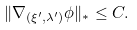Convert formula to latex. <formula><loc_0><loc_0><loc_500><loc_500>\| \nabla _ { ( \xi ^ { \prime } , \lambda ^ { \prime } ) } \phi \| _ { * } \leq C .</formula> 